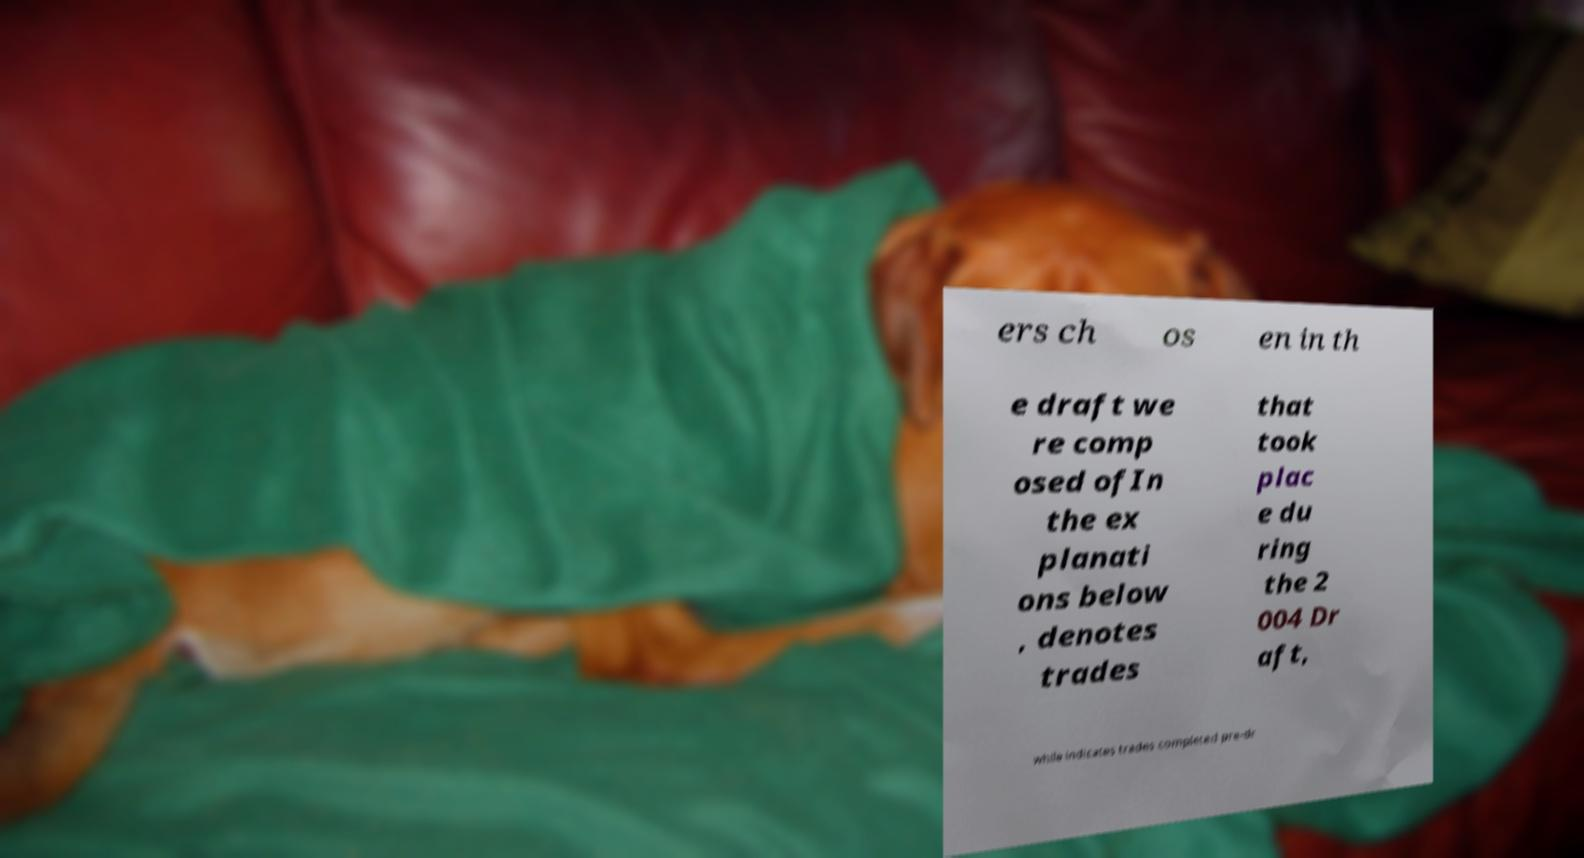For documentation purposes, I need the text within this image transcribed. Could you provide that? ers ch os en in th e draft we re comp osed ofIn the ex planati ons below , denotes trades that took plac e du ring the 2 004 Dr aft, while indicates trades completed pre-dr 